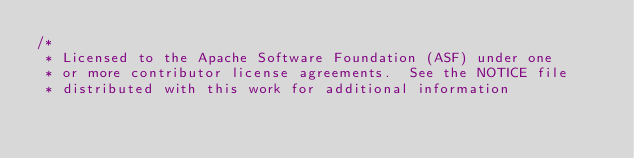Convert code to text. <code><loc_0><loc_0><loc_500><loc_500><_Java_>/*
 * Licensed to the Apache Software Foundation (ASF) under one
 * or more contributor license agreements.  See the NOTICE file
 * distributed with this work for additional information</code> 